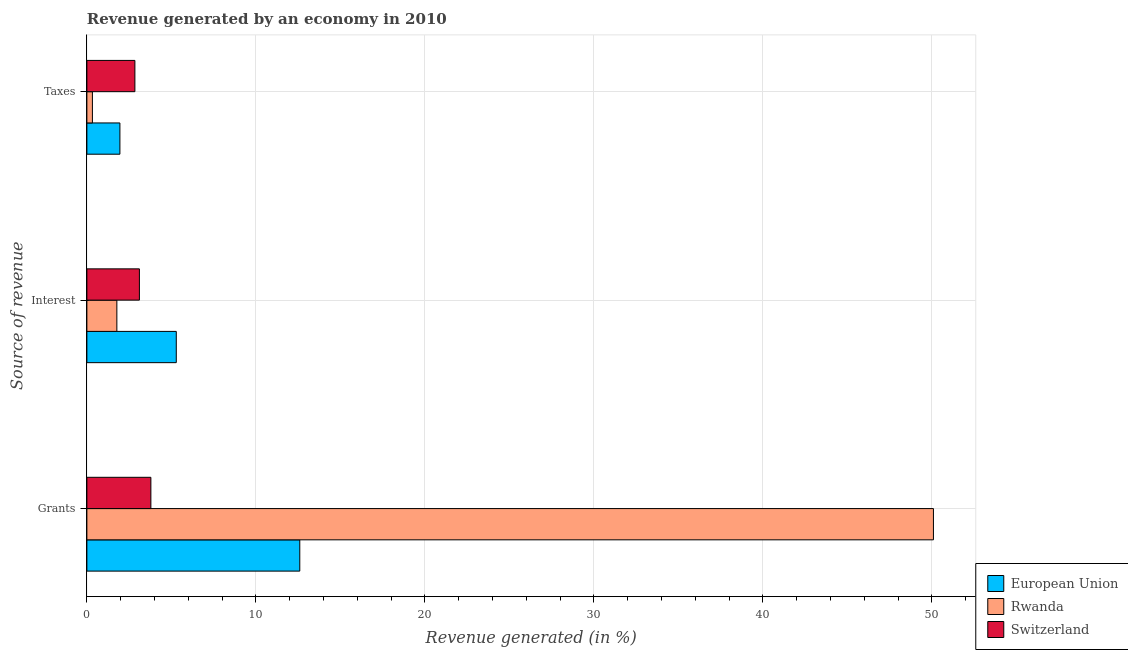How many different coloured bars are there?
Keep it short and to the point. 3. How many groups of bars are there?
Your response must be concise. 3. Are the number of bars per tick equal to the number of legend labels?
Provide a short and direct response. Yes. Are the number of bars on each tick of the Y-axis equal?
Make the answer very short. Yes. How many bars are there on the 3rd tick from the top?
Your response must be concise. 3. How many bars are there on the 1st tick from the bottom?
Ensure brevity in your answer.  3. What is the label of the 2nd group of bars from the top?
Give a very brief answer. Interest. What is the percentage of revenue generated by taxes in Switzerland?
Your answer should be very brief. 2.84. Across all countries, what is the maximum percentage of revenue generated by grants?
Your answer should be very brief. 50.09. Across all countries, what is the minimum percentage of revenue generated by grants?
Your answer should be very brief. 3.79. In which country was the percentage of revenue generated by interest minimum?
Your answer should be compact. Rwanda. What is the total percentage of revenue generated by grants in the graph?
Provide a succinct answer. 66.48. What is the difference between the percentage of revenue generated by taxes in Switzerland and that in Rwanda?
Offer a very short reply. 2.51. What is the difference between the percentage of revenue generated by taxes in Switzerland and the percentage of revenue generated by grants in European Union?
Give a very brief answer. -9.76. What is the average percentage of revenue generated by grants per country?
Offer a terse response. 22.16. What is the difference between the percentage of revenue generated by taxes and percentage of revenue generated by grants in Switzerland?
Ensure brevity in your answer.  -0.95. In how many countries, is the percentage of revenue generated by taxes greater than 2 %?
Keep it short and to the point. 1. What is the ratio of the percentage of revenue generated by grants in European Union to that in Rwanda?
Provide a short and direct response. 0.25. Is the percentage of revenue generated by taxes in Switzerland less than that in European Union?
Make the answer very short. No. What is the difference between the highest and the second highest percentage of revenue generated by interest?
Provide a short and direct response. 2.18. What is the difference between the highest and the lowest percentage of revenue generated by taxes?
Provide a short and direct response. 2.51. In how many countries, is the percentage of revenue generated by grants greater than the average percentage of revenue generated by grants taken over all countries?
Offer a terse response. 1. Is the sum of the percentage of revenue generated by interest in Rwanda and European Union greater than the maximum percentage of revenue generated by taxes across all countries?
Your answer should be compact. Yes. What does the 2nd bar from the top in Interest represents?
Your answer should be compact. Rwanda. How many countries are there in the graph?
Your answer should be very brief. 3. What is the difference between two consecutive major ticks on the X-axis?
Your answer should be compact. 10. Does the graph contain any zero values?
Make the answer very short. No. How many legend labels are there?
Offer a very short reply. 3. How are the legend labels stacked?
Ensure brevity in your answer.  Vertical. What is the title of the graph?
Provide a short and direct response. Revenue generated by an economy in 2010. What is the label or title of the X-axis?
Make the answer very short. Revenue generated (in %). What is the label or title of the Y-axis?
Your answer should be very brief. Source of revenue. What is the Revenue generated (in %) in European Union in Grants?
Your response must be concise. 12.6. What is the Revenue generated (in %) in Rwanda in Grants?
Provide a succinct answer. 50.09. What is the Revenue generated (in %) in Switzerland in Grants?
Provide a short and direct response. 3.79. What is the Revenue generated (in %) of European Union in Interest?
Give a very brief answer. 5.29. What is the Revenue generated (in %) in Rwanda in Interest?
Make the answer very short. 1.77. What is the Revenue generated (in %) of Switzerland in Interest?
Offer a very short reply. 3.11. What is the Revenue generated (in %) of European Union in Taxes?
Your answer should be compact. 1.95. What is the Revenue generated (in %) of Rwanda in Taxes?
Ensure brevity in your answer.  0.33. What is the Revenue generated (in %) of Switzerland in Taxes?
Your answer should be very brief. 2.84. Across all Source of revenue, what is the maximum Revenue generated (in %) of European Union?
Give a very brief answer. 12.6. Across all Source of revenue, what is the maximum Revenue generated (in %) of Rwanda?
Keep it short and to the point. 50.09. Across all Source of revenue, what is the maximum Revenue generated (in %) in Switzerland?
Ensure brevity in your answer.  3.79. Across all Source of revenue, what is the minimum Revenue generated (in %) in European Union?
Provide a succinct answer. 1.95. Across all Source of revenue, what is the minimum Revenue generated (in %) in Rwanda?
Offer a very short reply. 0.33. Across all Source of revenue, what is the minimum Revenue generated (in %) in Switzerland?
Your answer should be compact. 2.84. What is the total Revenue generated (in %) in European Union in the graph?
Provide a short and direct response. 19.84. What is the total Revenue generated (in %) of Rwanda in the graph?
Your answer should be compact. 52.19. What is the total Revenue generated (in %) in Switzerland in the graph?
Offer a terse response. 9.74. What is the difference between the Revenue generated (in %) of European Union in Grants and that in Interest?
Make the answer very short. 7.31. What is the difference between the Revenue generated (in %) of Rwanda in Grants and that in Interest?
Your answer should be very brief. 48.32. What is the difference between the Revenue generated (in %) in Switzerland in Grants and that in Interest?
Keep it short and to the point. 0.68. What is the difference between the Revenue generated (in %) of European Union in Grants and that in Taxes?
Ensure brevity in your answer.  10.64. What is the difference between the Revenue generated (in %) of Rwanda in Grants and that in Taxes?
Give a very brief answer. 49.77. What is the difference between the Revenue generated (in %) of Switzerland in Grants and that in Taxes?
Provide a succinct answer. 0.95. What is the difference between the Revenue generated (in %) of European Union in Interest and that in Taxes?
Give a very brief answer. 3.34. What is the difference between the Revenue generated (in %) in Rwanda in Interest and that in Taxes?
Give a very brief answer. 1.45. What is the difference between the Revenue generated (in %) in Switzerland in Interest and that in Taxes?
Provide a short and direct response. 0.27. What is the difference between the Revenue generated (in %) in European Union in Grants and the Revenue generated (in %) in Rwanda in Interest?
Offer a very short reply. 10.82. What is the difference between the Revenue generated (in %) in European Union in Grants and the Revenue generated (in %) in Switzerland in Interest?
Make the answer very short. 9.49. What is the difference between the Revenue generated (in %) of Rwanda in Grants and the Revenue generated (in %) of Switzerland in Interest?
Give a very brief answer. 46.98. What is the difference between the Revenue generated (in %) of European Union in Grants and the Revenue generated (in %) of Rwanda in Taxes?
Ensure brevity in your answer.  12.27. What is the difference between the Revenue generated (in %) of European Union in Grants and the Revenue generated (in %) of Switzerland in Taxes?
Give a very brief answer. 9.76. What is the difference between the Revenue generated (in %) of Rwanda in Grants and the Revenue generated (in %) of Switzerland in Taxes?
Your answer should be very brief. 47.25. What is the difference between the Revenue generated (in %) in European Union in Interest and the Revenue generated (in %) in Rwanda in Taxes?
Your answer should be very brief. 4.96. What is the difference between the Revenue generated (in %) in European Union in Interest and the Revenue generated (in %) in Switzerland in Taxes?
Your response must be concise. 2.45. What is the difference between the Revenue generated (in %) in Rwanda in Interest and the Revenue generated (in %) in Switzerland in Taxes?
Make the answer very short. -1.07. What is the average Revenue generated (in %) of European Union per Source of revenue?
Offer a very short reply. 6.61. What is the average Revenue generated (in %) in Rwanda per Source of revenue?
Your response must be concise. 17.4. What is the average Revenue generated (in %) in Switzerland per Source of revenue?
Provide a succinct answer. 3.25. What is the difference between the Revenue generated (in %) of European Union and Revenue generated (in %) of Rwanda in Grants?
Ensure brevity in your answer.  -37.49. What is the difference between the Revenue generated (in %) of European Union and Revenue generated (in %) of Switzerland in Grants?
Your answer should be compact. 8.81. What is the difference between the Revenue generated (in %) of Rwanda and Revenue generated (in %) of Switzerland in Grants?
Make the answer very short. 46.31. What is the difference between the Revenue generated (in %) in European Union and Revenue generated (in %) in Rwanda in Interest?
Offer a very short reply. 3.52. What is the difference between the Revenue generated (in %) in European Union and Revenue generated (in %) in Switzerland in Interest?
Give a very brief answer. 2.18. What is the difference between the Revenue generated (in %) of Rwanda and Revenue generated (in %) of Switzerland in Interest?
Keep it short and to the point. -1.33. What is the difference between the Revenue generated (in %) in European Union and Revenue generated (in %) in Rwanda in Taxes?
Keep it short and to the point. 1.63. What is the difference between the Revenue generated (in %) of European Union and Revenue generated (in %) of Switzerland in Taxes?
Ensure brevity in your answer.  -0.89. What is the difference between the Revenue generated (in %) in Rwanda and Revenue generated (in %) in Switzerland in Taxes?
Offer a terse response. -2.51. What is the ratio of the Revenue generated (in %) of European Union in Grants to that in Interest?
Offer a terse response. 2.38. What is the ratio of the Revenue generated (in %) in Rwanda in Grants to that in Interest?
Provide a short and direct response. 28.23. What is the ratio of the Revenue generated (in %) of Switzerland in Grants to that in Interest?
Keep it short and to the point. 1.22. What is the ratio of the Revenue generated (in %) of European Union in Grants to that in Taxes?
Make the answer very short. 6.45. What is the ratio of the Revenue generated (in %) of Rwanda in Grants to that in Taxes?
Give a very brief answer. 152.96. What is the ratio of the Revenue generated (in %) in Switzerland in Grants to that in Taxes?
Make the answer very short. 1.33. What is the ratio of the Revenue generated (in %) in European Union in Interest to that in Taxes?
Give a very brief answer. 2.71. What is the ratio of the Revenue generated (in %) in Rwanda in Interest to that in Taxes?
Make the answer very short. 5.42. What is the ratio of the Revenue generated (in %) of Switzerland in Interest to that in Taxes?
Provide a succinct answer. 1.09. What is the difference between the highest and the second highest Revenue generated (in %) of European Union?
Your answer should be compact. 7.31. What is the difference between the highest and the second highest Revenue generated (in %) in Rwanda?
Your answer should be very brief. 48.32. What is the difference between the highest and the second highest Revenue generated (in %) in Switzerland?
Your response must be concise. 0.68. What is the difference between the highest and the lowest Revenue generated (in %) of European Union?
Provide a succinct answer. 10.64. What is the difference between the highest and the lowest Revenue generated (in %) of Rwanda?
Provide a short and direct response. 49.77. What is the difference between the highest and the lowest Revenue generated (in %) in Switzerland?
Your answer should be very brief. 0.95. 